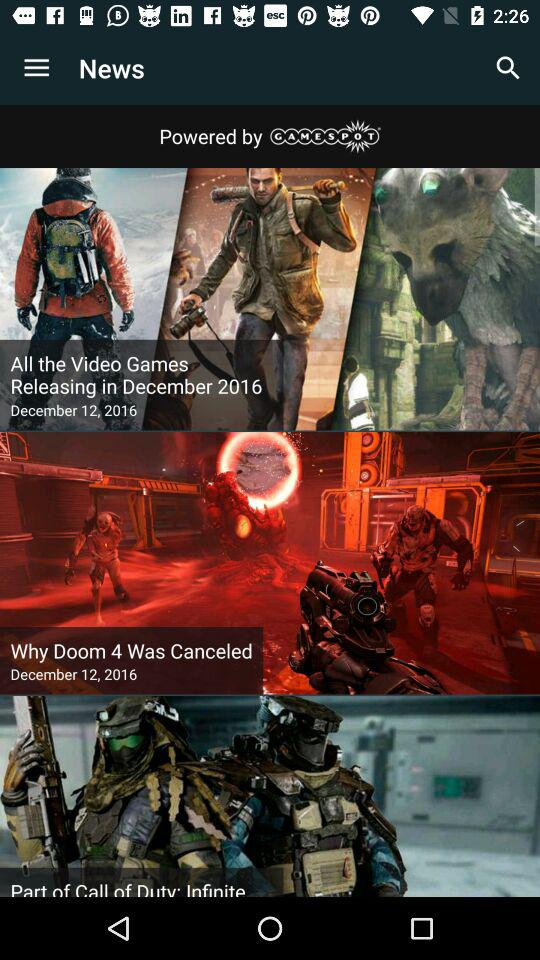How many news items are there?
Answer the question using a single word or phrase. 3 